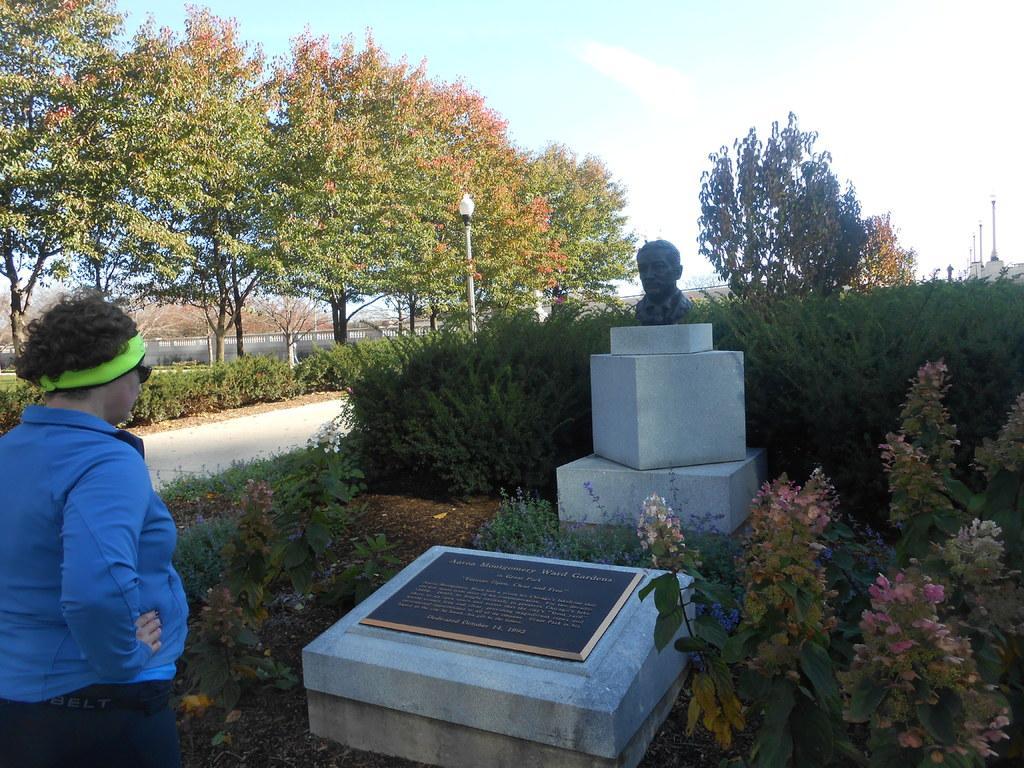How would you summarize this image in a sentence or two? In the picture we can see a gravestone with some words on it and near to it, we can see a sculpture of the man on the stone and around it we can see plants with flowers in it and behind it, we can see many plants and pole with light and near to the grave stone we can also see a person standing and in the background we can see many trees and a part of the sky. 